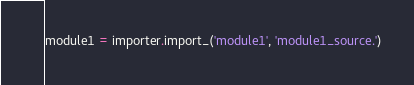Convert code to text. <code><loc_0><loc_0><loc_500><loc_500><_Python_>module1 = importer.import_('module1', 'module1_source.')
</code> 